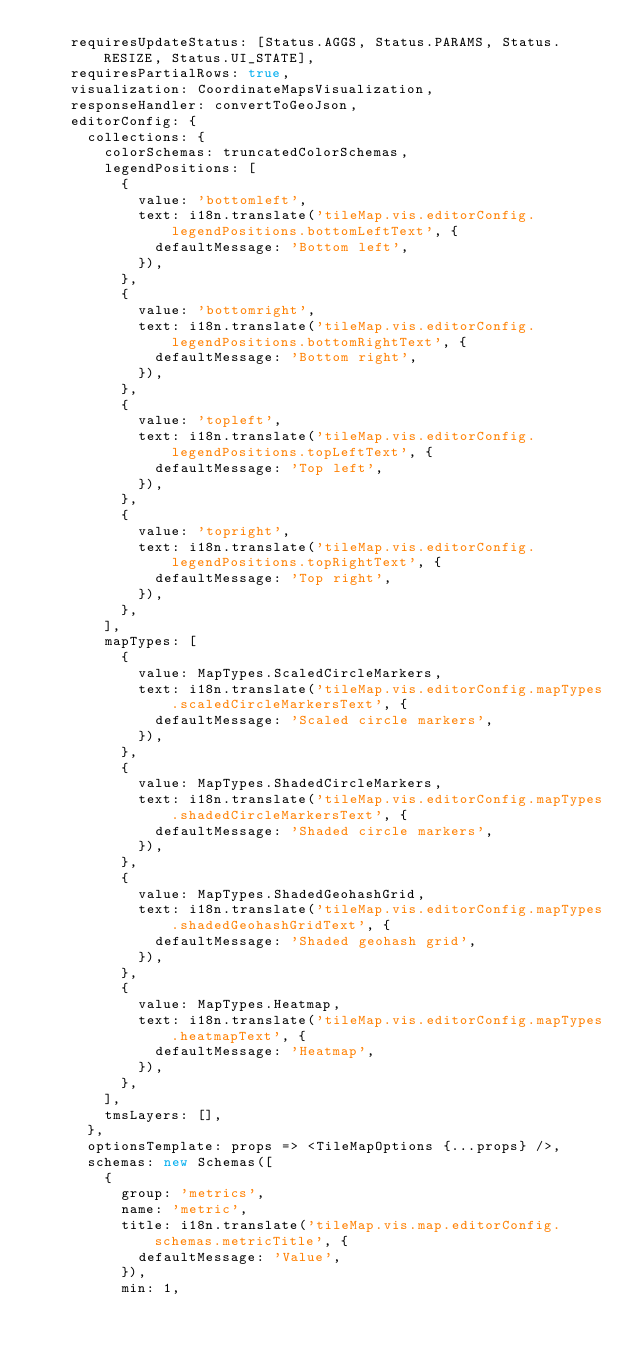<code> <loc_0><loc_0><loc_500><loc_500><_JavaScript_>    requiresUpdateStatus: [Status.AGGS, Status.PARAMS, Status.RESIZE, Status.UI_STATE],
    requiresPartialRows: true,
    visualization: CoordinateMapsVisualization,
    responseHandler: convertToGeoJson,
    editorConfig: {
      collections: {
        colorSchemas: truncatedColorSchemas,
        legendPositions: [
          {
            value: 'bottomleft',
            text: i18n.translate('tileMap.vis.editorConfig.legendPositions.bottomLeftText', {
              defaultMessage: 'Bottom left',
            }),
          },
          {
            value: 'bottomright',
            text: i18n.translate('tileMap.vis.editorConfig.legendPositions.bottomRightText', {
              defaultMessage: 'Bottom right',
            }),
          },
          {
            value: 'topleft',
            text: i18n.translate('tileMap.vis.editorConfig.legendPositions.topLeftText', {
              defaultMessage: 'Top left',
            }),
          },
          {
            value: 'topright',
            text: i18n.translate('tileMap.vis.editorConfig.legendPositions.topRightText', {
              defaultMessage: 'Top right',
            }),
          },
        ],
        mapTypes: [
          {
            value: MapTypes.ScaledCircleMarkers,
            text: i18n.translate('tileMap.vis.editorConfig.mapTypes.scaledCircleMarkersText', {
              defaultMessage: 'Scaled circle markers',
            }),
          },
          {
            value: MapTypes.ShadedCircleMarkers,
            text: i18n.translate('tileMap.vis.editorConfig.mapTypes.shadedCircleMarkersText', {
              defaultMessage: 'Shaded circle markers',
            }),
          },
          {
            value: MapTypes.ShadedGeohashGrid,
            text: i18n.translate('tileMap.vis.editorConfig.mapTypes.shadedGeohashGridText', {
              defaultMessage: 'Shaded geohash grid',
            }),
          },
          {
            value: MapTypes.Heatmap,
            text: i18n.translate('tileMap.vis.editorConfig.mapTypes.heatmapText', {
              defaultMessage: 'Heatmap',
            }),
          },
        ],
        tmsLayers: [],
      },
      optionsTemplate: props => <TileMapOptions {...props} />,
      schemas: new Schemas([
        {
          group: 'metrics',
          name: 'metric',
          title: i18n.translate('tileMap.vis.map.editorConfig.schemas.metricTitle', {
            defaultMessage: 'Value',
          }),
          min: 1,</code> 